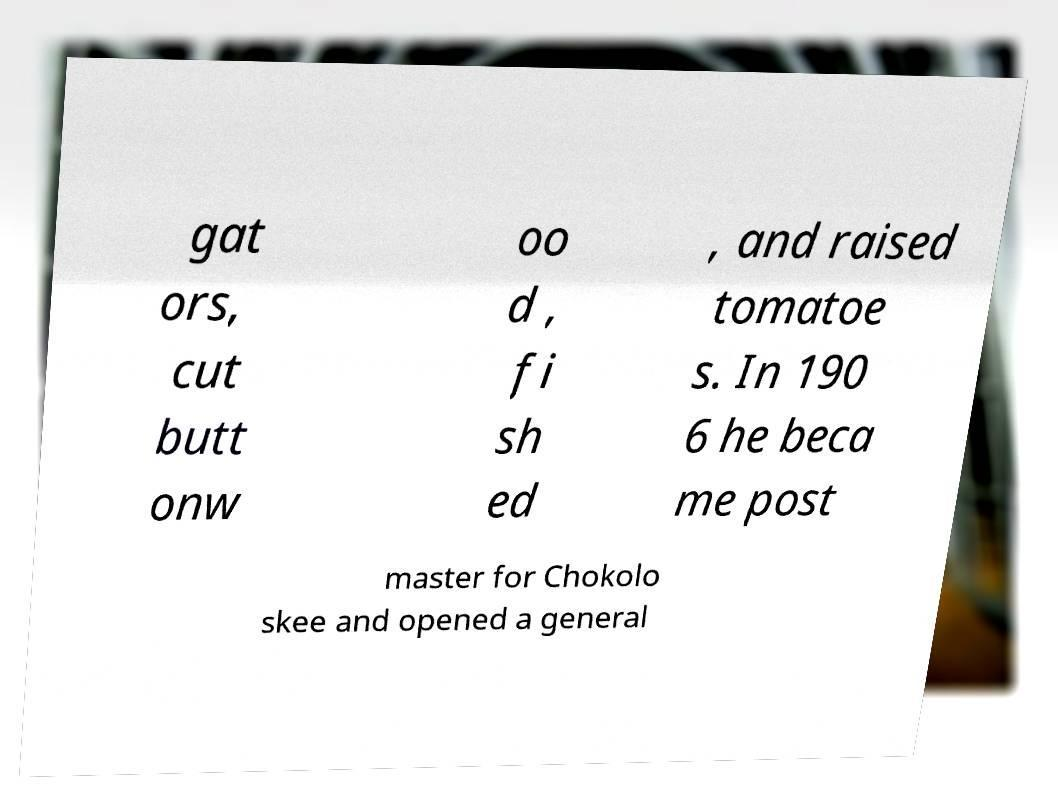Please read and relay the text visible in this image. What does it say? gat ors, cut butt onw oo d , fi sh ed , and raised tomatoe s. In 190 6 he beca me post master for Chokolo skee and opened a general 